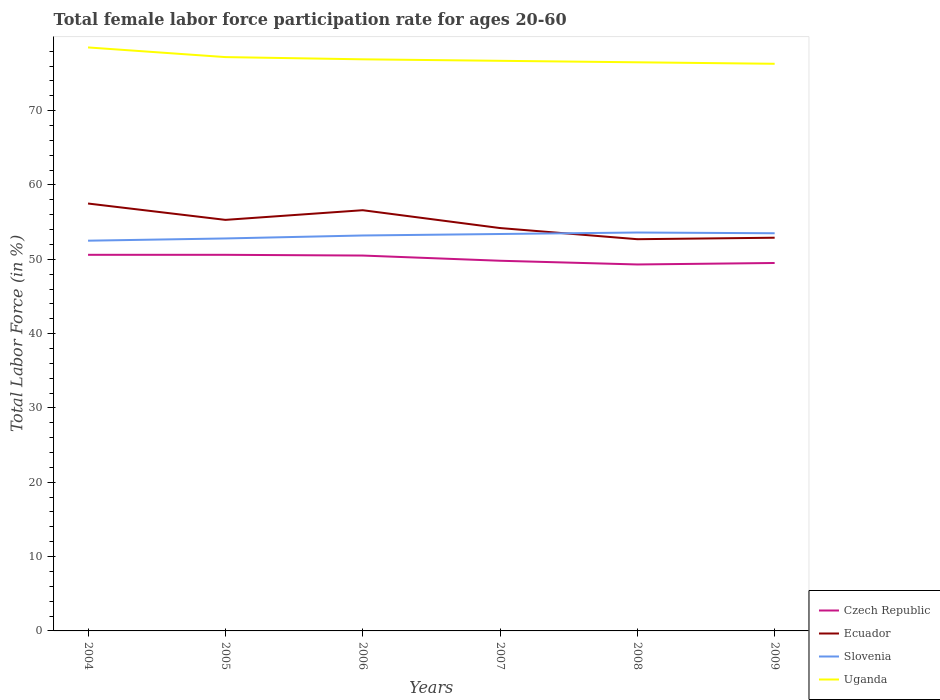How many different coloured lines are there?
Make the answer very short. 4. Does the line corresponding to Czech Republic intersect with the line corresponding to Slovenia?
Ensure brevity in your answer.  No. Is the number of lines equal to the number of legend labels?
Your answer should be compact. Yes. Across all years, what is the maximum female labor force participation rate in Uganda?
Ensure brevity in your answer.  76.3. In which year was the female labor force participation rate in Uganda maximum?
Your answer should be compact. 2009. What is the total female labor force participation rate in Ecuador in the graph?
Make the answer very short. 3.9. What is the difference between the highest and the second highest female labor force participation rate in Slovenia?
Offer a terse response. 1.1. What is the difference between the highest and the lowest female labor force participation rate in Uganda?
Ensure brevity in your answer.  2. How many lines are there?
Provide a succinct answer. 4. How many years are there in the graph?
Keep it short and to the point. 6. Are the values on the major ticks of Y-axis written in scientific E-notation?
Your answer should be compact. No. How many legend labels are there?
Provide a short and direct response. 4. How are the legend labels stacked?
Your response must be concise. Vertical. What is the title of the graph?
Keep it short and to the point. Total female labor force participation rate for ages 20-60. Does "Iceland" appear as one of the legend labels in the graph?
Offer a terse response. No. What is the Total Labor Force (in %) in Czech Republic in 2004?
Offer a terse response. 50.6. What is the Total Labor Force (in %) in Ecuador in 2004?
Your answer should be very brief. 57.5. What is the Total Labor Force (in %) in Slovenia in 2004?
Make the answer very short. 52.5. What is the Total Labor Force (in %) in Uganda in 2004?
Offer a very short reply. 78.5. What is the Total Labor Force (in %) in Czech Republic in 2005?
Your answer should be very brief. 50.6. What is the Total Labor Force (in %) of Ecuador in 2005?
Offer a terse response. 55.3. What is the Total Labor Force (in %) in Slovenia in 2005?
Your response must be concise. 52.8. What is the Total Labor Force (in %) of Uganda in 2005?
Ensure brevity in your answer.  77.2. What is the Total Labor Force (in %) of Czech Republic in 2006?
Ensure brevity in your answer.  50.5. What is the Total Labor Force (in %) of Ecuador in 2006?
Your response must be concise. 56.6. What is the Total Labor Force (in %) of Slovenia in 2006?
Your answer should be compact. 53.2. What is the Total Labor Force (in %) of Uganda in 2006?
Make the answer very short. 76.9. What is the Total Labor Force (in %) in Czech Republic in 2007?
Provide a short and direct response. 49.8. What is the Total Labor Force (in %) in Ecuador in 2007?
Your answer should be compact. 54.2. What is the Total Labor Force (in %) of Slovenia in 2007?
Offer a terse response. 53.4. What is the Total Labor Force (in %) in Uganda in 2007?
Your answer should be compact. 76.7. What is the Total Labor Force (in %) of Czech Republic in 2008?
Offer a terse response. 49.3. What is the Total Labor Force (in %) of Ecuador in 2008?
Your answer should be compact. 52.7. What is the Total Labor Force (in %) of Slovenia in 2008?
Your answer should be very brief. 53.6. What is the Total Labor Force (in %) in Uganda in 2008?
Keep it short and to the point. 76.5. What is the Total Labor Force (in %) in Czech Republic in 2009?
Make the answer very short. 49.5. What is the Total Labor Force (in %) of Ecuador in 2009?
Offer a terse response. 52.9. What is the Total Labor Force (in %) in Slovenia in 2009?
Provide a short and direct response. 53.5. What is the Total Labor Force (in %) of Uganda in 2009?
Your answer should be very brief. 76.3. Across all years, what is the maximum Total Labor Force (in %) of Czech Republic?
Make the answer very short. 50.6. Across all years, what is the maximum Total Labor Force (in %) in Ecuador?
Give a very brief answer. 57.5. Across all years, what is the maximum Total Labor Force (in %) in Slovenia?
Offer a very short reply. 53.6. Across all years, what is the maximum Total Labor Force (in %) in Uganda?
Keep it short and to the point. 78.5. Across all years, what is the minimum Total Labor Force (in %) of Czech Republic?
Provide a succinct answer. 49.3. Across all years, what is the minimum Total Labor Force (in %) of Ecuador?
Your answer should be very brief. 52.7. Across all years, what is the minimum Total Labor Force (in %) of Slovenia?
Keep it short and to the point. 52.5. Across all years, what is the minimum Total Labor Force (in %) of Uganda?
Your answer should be very brief. 76.3. What is the total Total Labor Force (in %) of Czech Republic in the graph?
Your answer should be very brief. 300.3. What is the total Total Labor Force (in %) of Ecuador in the graph?
Provide a succinct answer. 329.2. What is the total Total Labor Force (in %) in Slovenia in the graph?
Give a very brief answer. 319. What is the total Total Labor Force (in %) in Uganda in the graph?
Provide a succinct answer. 462.1. What is the difference between the Total Labor Force (in %) of Czech Republic in 2004 and that in 2006?
Give a very brief answer. 0.1. What is the difference between the Total Labor Force (in %) of Uganda in 2004 and that in 2006?
Offer a terse response. 1.6. What is the difference between the Total Labor Force (in %) of Czech Republic in 2004 and that in 2007?
Your response must be concise. 0.8. What is the difference between the Total Labor Force (in %) in Ecuador in 2004 and that in 2007?
Offer a very short reply. 3.3. What is the difference between the Total Labor Force (in %) in Slovenia in 2004 and that in 2007?
Give a very brief answer. -0.9. What is the difference between the Total Labor Force (in %) in Uganda in 2004 and that in 2007?
Ensure brevity in your answer.  1.8. What is the difference between the Total Labor Force (in %) of Czech Republic in 2004 and that in 2008?
Provide a short and direct response. 1.3. What is the difference between the Total Labor Force (in %) in Ecuador in 2004 and that in 2008?
Make the answer very short. 4.8. What is the difference between the Total Labor Force (in %) in Slovenia in 2004 and that in 2008?
Ensure brevity in your answer.  -1.1. What is the difference between the Total Labor Force (in %) of Czech Republic in 2004 and that in 2009?
Make the answer very short. 1.1. What is the difference between the Total Labor Force (in %) of Ecuador in 2004 and that in 2009?
Your answer should be very brief. 4.6. What is the difference between the Total Labor Force (in %) of Czech Republic in 2005 and that in 2006?
Provide a succinct answer. 0.1. What is the difference between the Total Labor Force (in %) of Ecuador in 2005 and that in 2006?
Give a very brief answer. -1.3. What is the difference between the Total Labor Force (in %) of Uganda in 2005 and that in 2006?
Your answer should be compact. 0.3. What is the difference between the Total Labor Force (in %) of Czech Republic in 2005 and that in 2007?
Provide a short and direct response. 0.8. What is the difference between the Total Labor Force (in %) of Ecuador in 2005 and that in 2007?
Your answer should be compact. 1.1. What is the difference between the Total Labor Force (in %) in Slovenia in 2005 and that in 2007?
Your answer should be compact. -0.6. What is the difference between the Total Labor Force (in %) of Uganda in 2005 and that in 2007?
Give a very brief answer. 0.5. What is the difference between the Total Labor Force (in %) of Uganda in 2005 and that in 2008?
Your answer should be compact. 0.7. What is the difference between the Total Labor Force (in %) in Czech Republic in 2005 and that in 2009?
Offer a very short reply. 1.1. What is the difference between the Total Labor Force (in %) in Ecuador in 2005 and that in 2009?
Give a very brief answer. 2.4. What is the difference between the Total Labor Force (in %) of Czech Republic in 2006 and that in 2007?
Keep it short and to the point. 0.7. What is the difference between the Total Labor Force (in %) in Slovenia in 2006 and that in 2007?
Provide a succinct answer. -0.2. What is the difference between the Total Labor Force (in %) in Czech Republic in 2006 and that in 2008?
Provide a short and direct response. 1.2. What is the difference between the Total Labor Force (in %) of Ecuador in 2006 and that in 2008?
Keep it short and to the point. 3.9. What is the difference between the Total Labor Force (in %) in Slovenia in 2006 and that in 2008?
Offer a terse response. -0.4. What is the difference between the Total Labor Force (in %) of Uganda in 2006 and that in 2008?
Your answer should be compact. 0.4. What is the difference between the Total Labor Force (in %) of Ecuador in 2006 and that in 2009?
Provide a short and direct response. 3.7. What is the difference between the Total Labor Force (in %) in Slovenia in 2006 and that in 2009?
Keep it short and to the point. -0.3. What is the difference between the Total Labor Force (in %) of Uganda in 2006 and that in 2009?
Make the answer very short. 0.6. What is the difference between the Total Labor Force (in %) of Uganda in 2007 and that in 2008?
Your response must be concise. 0.2. What is the difference between the Total Labor Force (in %) of Slovenia in 2007 and that in 2009?
Your response must be concise. -0.1. What is the difference between the Total Labor Force (in %) of Uganda in 2007 and that in 2009?
Provide a succinct answer. 0.4. What is the difference between the Total Labor Force (in %) in Czech Republic in 2008 and that in 2009?
Offer a very short reply. -0.2. What is the difference between the Total Labor Force (in %) in Ecuador in 2008 and that in 2009?
Make the answer very short. -0.2. What is the difference between the Total Labor Force (in %) in Slovenia in 2008 and that in 2009?
Your answer should be very brief. 0.1. What is the difference between the Total Labor Force (in %) in Uganda in 2008 and that in 2009?
Offer a very short reply. 0.2. What is the difference between the Total Labor Force (in %) of Czech Republic in 2004 and the Total Labor Force (in %) of Ecuador in 2005?
Your answer should be very brief. -4.7. What is the difference between the Total Labor Force (in %) of Czech Republic in 2004 and the Total Labor Force (in %) of Slovenia in 2005?
Your response must be concise. -2.2. What is the difference between the Total Labor Force (in %) of Czech Republic in 2004 and the Total Labor Force (in %) of Uganda in 2005?
Offer a terse response. -26.6. What is the difference between the Total Labor Force (in %) of Ecuador in 2004 and the Total Labor Force (in %) of Uganda in 2005?
Provide a succinct answer. -19.7. What is the difference between the Total Labor Force (in %) of Slovenia in 2004 and the Total Labor Force (in %) of Uganda in 2005?
Provide a succinct answer. -24.7. What is the difference between the Total Labor Force (in %) in Czech Republic in 2004 and the Total Labor Force (in %) in Slovenia in 2006?
Ensure brevity in your answer.  -2.6. What is the difference between the Total Labor Force (in %) in Czech Republic in 2004 and the Total Labor Force (in %) in Uganda in 2006?
Keep it short and to the point. -26.3. What is the difference between the Total Labor Force (in %) in Ecuador in 2004 and the Total Labor Force (in %) in Uganda in 2006?
Provide a short and direct response. -19.4. What is the difference between the Total Labor Force (in %) of Slovenia in 2004 and the Total Labor Force (in %) of Uganda in 2006?
Your response must be concise. -24.4. What is the difference between the Total Labor Force (in %) in Czech Republic in 2004 and the Total Labor Force (in %) in Ecuador in 2007?
Offer a very short reply. -3.6. What is the difference between the Total Labor Force (in %) in Czech Republic in 2004 and the Total Labor Force (in %) in Uganda in 2007?
Provide a succinct answer. -26.1. What is the difference between the Total Labor Force (in %) of Ecuador in 2004 and the Total Labor Force (in %) of Slovenia in 2007?
Your answer should be compact. 4.1. What is the difference between the Total Labor Force (in %) of Ecuador in 2004 and the Total Labor Force (in %) of Uganda in 2007?
Offer a very short reply. -19.2. What is the difference between the Total Labor Force (in %) of Slovenia in 2004 and the Total Labor Force (in %) of Uganda in 2007?
Provide a succinct answer. -24.2. What is the difference between the Total Labor Force (in %) in Czech Republic in 2004 and the Total Labor Force (in %) in Ecuador in 2008?
Give a very brief answer. -2.1. What is the difference between the Total Labor Force (in %) in Czech Republic in 2004 and the Total Labor Force (in %) in Slovenia in 2008?
Make the answer very short. -3. What is the difference between the Total Labor Force (in %) in Czech Republic in 2004 and the Total Labor Force (in %) in Uganda in 2008?
Your response must be concise. -25.9. What is the difference between the Total Labor Force (in %) in Ecuador in 2004 and the Total Labor Force (in %) in Slovenia in 2008?
Offer a terse response. 3.9. What is the difference between the Total Labor Force (in %) in Ecuador in 2004 and the Total Labor Force (in %) in Uganda in 2008?
Make the answer very short. -19. What is the difference between the Total Labor Force (in %) of Czech Republic in 2004 and the Total Labor Force (in %) of Ecuador in 2009?
Your answer should be compact. -2.3. What is the difference between the Total Labor Force (in %) in Czech Republic in 2004 and the Total Labor Force (in %) in Slovenia in 2009?
Give a very brief answer. -2.9. What is the difference between the Total Labor Force (in %) of Czech Republic in 2004 and the Total Labor Force (in %) of Uganda in 2009?
Your response must be concise. -25.7. What is the difference between the Total Labor Force (in %) of Ecuador in 2004 and the Total Labor Force (in %) of Uganda in 2009?
Keep it short and to the point. -18.8. What is the difference between the Total Labor Force (in %) in Slovenia in 2004 and the Total Labor Force (in %) in Uganda in 2009?
Provide a succinct answer. -23.8. What is the difference between the Total Labor Force (in %) of Czech Republic in 2005 and the Total Labor Force (in %) of Slovenia in 2006?
Ensure brevity in your answer.  -2.6. What is the difference between the Total Labor Force (in %) in Czech Republic in 2005 and the Total Labor Force (in %) in Uganda in 2006?
Provide a short and direct response. -26.3. What is the difference between the Total Labor Force (in %) of Ecuador in 2005 and the Total Labor Force (in %) of Uganda in 2006?
Your response must be concise. -21.6. What is the difference between the Total Labor Force (in %) in Slovenia in 2005 and the Total Labor Force (in %) in Uganda in 2006?
Offer a very short reply. -24.1. What is the difference between the Total Labor Force (in %) of Czech Republic in 2005 and the Total Labor Force (in %) of Uganda in 2007?
Keep it short and to the point. -26.1. What is the difference between the Total Labor Force (in %) in Ecuador in 2005 and the Total Labor Force (in %) in Uganda in 2007?
Your answer should be compact. -21.4. What is the difference between the Total Labor Force (in %) in Slovenia in 2005 and the Total Labor Force (in %) in Uganda in 2007?
Provide a short and direct response. -23.9. What is the difference between the Total Labor Force (in %) of Czech Republic in 2005 and the Total Labor Force (in %) of Ecuador in 2008?
Provide a succinct answer. -2.1. What is the difference between the Total Labor Force (in %) in Czech Republic in 2005 and the Total Labor Force (in %) in Uganda in 2008?
Your response must be concise. -25.9. What is the difference between the Total Labor Force (in %) of Ecuador in 2005 and the Total Labor Force (in %) of Uganda in 2008?
Provide a short and direct response. -21.2. What is the difference between the Total Labor Force (in %) of Slovenia in 2005 and the Total Labor Force (in %) of Uganda in 2008?
Offer a very short reply. -23.7. What is the difference between the Total Labor Force (in %) in Czech Republic in 2005 and the Total Labor Force (in %) in Slovenia in 2009?
Keep it short and to the point. -2.9. What is the difference between the Total Labor Force (in %) of Czech Republic in 2005 and the Total Labor Force (in %) of Uganda in 2009?
Provide a succinct answer. -25.7. What is the difference between the Total Labor Force (in %) of Ecuador in 2005 and the Total Labor Force (in %) of Slovenia in 2009?
Ensure brevity in your answer.  1.8. What is the difference between the Total Labor Force (in %) in Ecuador in 2005 and the Total Labor Force (in %) in Uganda in 2009?
Your answer should be very brief. -21. What is the difference between the Total Labor Force (in %) in Slovenia in 2005 and the Total Labor Force (in %) in Uganda in 2009?
Make the answer very short. -23.5. What is the difference between the Total Labor Force (in %) of Czech Republic in 2006 and the Total Labor Force (in %) of Ecuador in 2007?
Make the answer very short. -3.7. What is the difference between the Total Labor Force (in %) of Czech Republic in 2006 and the Total Labor Force (in %) of Uganda in 2007?
Make the answer very short. -26.2. What is the difference between the Total Labor Force (in %) of Ecuador in 2006 and the Total Labor Force (in %) of Uganda in 2007?
Keep it short and to the point. -20.1. What is the difference between the Total Labor Force (in %) in Slovenia in 2006 and the Total Labor Force (in %) in Uganda in 2007?
Your answer should be compact. -23.5. What is the difference between the Total Labor Force (in %) of Czech Republic in 2006 and the Total Labor Force (in %) of Ecuador in 2008?
Keep it short and to the point. -2.2. What is the difference between the Total Labor Force (in %) in Czech Republic in 2006 and the Total Labor Force (in %) in Slovenia in 2008?
Your answer should be very brief. -3.1. What is the difference between the Total Labor Force (in %) in Czech Republic in 2006 and the Total Labor Force (in %) in Uganda in 2008?
Your answer should be very brief. -26. What is the difference between the Total Labor Force (in %) in Ecuador in 2006 and the Total Labor Force (in %) in Slovenia in 2008?
Make the answer very short. 3. What is the difference between the Total Labor Force (in %) of Ecuador in 2006 and the Total Labor Force (in %) of Uganda in 2008?
Provide a succinct answer. -19.9. What is the difference between the Total Labor Force (in %) of Slovenia in 2006 and the Total Labor Force (in %) of Uganda in 2008?
Offer a terse response. -23.3. What is the difference between the Total Labor Force (in %) of Czech Republic in 2006 and the Total Labor Force (in %) of Ecuador in 2009?
Your answer should be very brief. -2.4. What is the difference between the Total Labor Force (in %) in Czech Republic in 2006 and the Total Labor Force (in %) in Slovenia in 2009?
Your response must be concise. -3. What is the difference between the Total Labor Force (in %) in Czech Republic in 2006 and the Total Labor Force (in %) in Uganda in 2009?
Your answer should be very brief. -25.8. What is the difference between the Total Labor Force (in %) of Ecuador in 2006 and the Total Labor Force (in %) of Uganda in 2009?
Offer a terse response. -19.7. What is the difference between the Total Labor Force (in %) in Slovenia in 2006 and the Total Labor Force (in %) in Uganda in 2009?
Ensure brevity in your answer.  -23.1. What is the difference between the Total Labor Force (in %) in Czech Republic in 2007 and the Total Labor Force (in %) in Ecuador in 2008?
Provide a short and direct response. -2.9. What is the difference between the Total Labor Force (in %) in Czech Republic in 2007 and the Total Labor Force (in %) in Slovenia in 2008?
Your answer should be very brief. -3.8. What is the difference between the Total Labor Force (in %) in Czech Republic in 2007 and the Total Labor Force (in %) in Uganda in 2008?
Offer a very short reply. -26.7. What is the difference between the Total Labor Force (in %) of Ecuador in 2007 and the Total Labor Force (in %) of Uganda in 2008?
Provide a succinct answer. -22.3. What is the difference between the Total Labor Force (in %) of Slovenia in 2007 and the Total Labor Force (in %) of Uganda in 2008?
Make the answer very short. -23.1. What is the difference between the Total Labor Force (in %) in Czech Republic in 2007 and the Total Labor Force (in %) in Slovenia in 2009?
Make the answer very short. -3.7. What is the difference between the Total Labor Force (in %) of Czech Republic in 2007 and the Total Labor Force (in %) of Uganda in 2009?
Offer a very short reply. -26.5. What is the difference between the Total Labor Force (in %) in Ecuador in 2007 and the Total Labor Force (in %) in Slovenia in 2009?
Give a very brief answer. 0.7. What is the difference between the Total Labor Force (in %) in Ecuador in 2007 and the Total Labor Force (in %) in Uganda in 2009?
Your answer should be very brief. -22.1. What is the difference between the Total Labor Force (in %) in Slovenia in 2007 and the Total Labor Force (in %) in Uganda in 2009?
Ensure brevity in your answer.  -22.9. What is the difference between the Total Labor Force (in %) of Czech Republic in 2008 and the Total Labor Force (in %) of Ecuador in 2009?
Offer a terse response. -3.6. What is the difference between the Total Labor Force (in %) of Ecuador in 2008 and the Total Labor Force (in %) of Uganda in 2009?
Offer a terse response. -23.6. What is the difference between the Total Labor Force (in %) in Slovenia in 2008 and the Total Labor Force (in %) in Uganda in 2009?
Keep it short and to the point. -22.7. What is the average Total Labor Force (in %) in Czech Republic per year?
Provide a succinct answer. 50.05. What is the average Total Labor Force (in %) of Ecuador per year?
Your answer should be very brief. 54.87. What is the average Total Labor Force (in %) in Slovenia per year?
Provide a succinct answer. 53.17. What is the average Total Labor Force (in %) in Uganda per year?
Provide a succinct answer. 77.02. In the year 2004, what is the difference between the Total Labor Force (in %) in Czech Republic and Total Labor Force (in %) in Slovenia?
Offer a very short reply. -1.9. In the year 2004, what is the difference between the Total Labor Force (in %) in Czech Republic and Total Labor Force (in %) in Uganda?
Your answer should be compact. -27.9. In the year 2004, what is the difference between the Total Labor Force (in %) of Slovenia and Total Labor Force (in %) of Uganda?
Offer a very short reply. -26. In the year 2005, what is the difference between the Total Labor Force (in %) in Czech Republic and Total Labor Force (in %) in Uganda?
Provide a short and direct response. -26.6. In the year 2005, what is the difference between the Total Labor Force (in %) of Ecuador and Total Labor Force (in %) of Uganda?
Make the answer very short. -21.9. In the year 2005, what is the difference between the Total Labor Force (in %) in Slovenia and Total Labor Force (in %) in Uganda?
Offer a terse response. -24.4. In the year 2006, what is the difference between the Total Labor Force (in %) in Czech Republic and Total Labor Force (in %) in Uganda?
Provide a succinct answer. -26.4. In the year 2006, what is the difference between the Total Labor Force (in %) in Ecuador and Total Labor Force (in %) in Slovenia?
Offer a terse response. 3.4. In the year 2006, what is the difference between the Total Labor Force (in %) in Ecuador and Total Labor Force (in %) in Uganda?
Keep it short and to the point. -20.3. In the year 2006, what is the difference between the Total Labor Force (in %) in Slovenia and Total Labor Force (in %) in Uganda?
Provide a short and direct response. -23.7. In the year 2007, what is the difference between the Total Labor Force (in %) of Czech Republic and Total Labor Force (in %) of Slovenia?
Make the answer very short. -3.6. In the year 2007, what is the difference between the Total Labor Force (in %) of Czech Republic and Total Labor Force (in %) of Uganda?
Give a very brief answer. -26.9. In the year 2007, what is the difference between the Total Labor Force (in %) in Ecuador and Total Labor Force (in %) in Slovenia?
Keep it short and to the point. 0.8. In the year 2007, what is the difference between the Total Labor Force (in %) in Ecuador and Total Labor Force (in %) in Uganda?
Your answer should be very brief. -22.5. In the year 2007, what is the difference between the Total Labor Force (in %) in Slovenia and Total Labor Force (in %) in Uganda?
Give a very brief answer. -23.3. In the year 2008, what is the difference between the Total Labor Force (in %) in Czech Republic and Total Labor Force (in %) in Ecuador?
Your answer should be compact. -3.4. In the year 2008, what is the difference between the Total Labor Force (in %) of Czech Republic and Total Labor Force (in %) of Uganda?
Provide a succinct answer. -27.2. In the year 2008, what is the difference between the Total Labor Force (in %) of Ecuador and Total Labor Force (in %) of Slovenia?
Your answer should be very brief. -0.9. In the year 2008, what is the difference between the Total Labor Force (in %) in Ecuador and Total Labor Force (in %) in Uganda?
Ensure brevity in your answer.  -23.8. In the year 2008, what is the difference between the Total Labor Force (in %) of Slovenia and Total Labor Force (in %) of Uganda?
Ensure brevity in your answer.  -22.9. In the year 2009, what is the difference between the Total Labor Force (in %) of Czech Republic and Total Labor Force (in %) of Slovenia?
Ensure brevity in your answer.  -4. In the year 2009, what is the difference between the Total Labor Force (in %) of Czech Republic and Total Labor Force (in %) of Uganda?
Give a very brief answer. -26.8. In the year 2009, what is the difference between the Total Labor Force (in %) in Ecuador and Total Labor Force (in %) in Uganda?
Provide a succinct answer. -23.4. In the year 2009, what is the difference between the Total Labor Force (in %) of Slovenia and Total Labor Force (in %) of Uganda?
Offer a terse response. -22.8. What is the ratio of the Total Labor Force (in %) in Czech Republic in 2004 to that in 2005?
Offer a terse response. 1. What is the ratio of the Total Labor Force (in %) in Ecuador in 2004 to that in 2005?
Provide a succinct answer. 1.04. What is the ratio of the Total Labor Force (in %) of Uganda in 2004 to that in 2005?
Ensure brevity in your answer.  1.02. What is the ratio of the Total Labor Force (in %) in Ecuador in 2004 to that in 2006?
Provide a succinct answer. 1.02. What is the ratio of the Total Labor Force (in %) of Slovenia in 2004 to that in 2006?
Give a very brief answer. 0.99. What is the ratio of the Total Labor Force (in %) of Uganda in 2004 to that in 2006?
Your answer should be compact. 1.02. What is the ratio of the Total Labor Force (in %) in Czech Republic in 2004 to that in 2007?
Provide a succinct answer. 1.02. What is the ratio of the Total Labor Force (in %) of Ecuador in 2004 to that in 2007?
Offer a terse response. 1.06. What is the ratio of the Total Labor Force (in %) in Slovenia in 2004 to that in 2007?
Give a very brief answer. 0.98. What is the ratio of the Total Labor Force (in %) of Uganda in 2004 to that in 2007?
Offer a very short reply. 1.02. What is the ratio of the Total Labor Force (in %) of Czech Republic in 2004 to that in 2008?
Offer a very short reply. 1.03. What is the ratio of the Total Labor Force (in %) in Ecuador in 2004 to that in 2008?
Offer a very short reply. 1.09. What is the ratio of the Total Labor Force (in %) in Slovenia in 2004 to that in 2008?
Provide a succinct answer. 0.98. What is the ratio of the Total Labor Force (in %) in Uganda in 2004 to that in 2008?
Offer a terse response. 1.03. What is the ratio of the Total Labor Force (in %) of Czech Republic in 2004 to that in 2009?
Offer a very short reply. 1.02. What is the ratio of the Total Labor Force (in %) of Ecuador in 2004 to that in 2009?
Provide a succinct answer. 1.09. What is the ratio of the Total Labor Force (in %) in Slovenia in 2004 to that in 2009?
Keep it short and to the point. 0.98. What is the ratio of the Total Labor Force (in %) in Uganda in 2004 to that in 2009?
Make the answer very short. 1.03. What is the ratio of the Total Labor Force (in %) in Czech Republic in 2005 to that in 2006?
Ensure brevity in your answer.  1. What is the ratio of the Total Labor Force (in %) in Ecuador in 2005 to that in 2006?
Provide a short and direct response. 0.98. What is the ratio of the Total Labor Force (in %) in Slovenia in 2005 to that in 2006?
Provide a succinct answer. 0.99. What is the ratio of the Total Labor Force (in %) in Uganda in 2005 to that in 2006?
Your answer should be very brief. 1. What is the ratio of the Total Labor Force (in %) in Czech Republic in 2005 to that in 2007?
Provide a short and direct response. 1.02. What is the ratio of the Total Labor Force (in %) of Ecuador in 2005 to that in 2007?
Your response must be concise. 1.02. What is the ratio of the Total Labor Force (in %) of Slovenia in 2005 to that in 2007?
Make the answer very short. 0.99. What is the ratio of the Total Labor Force (in %) of Czech Republic in 2005 to that in 2008?
Provide a succinct answer. 1.03. What is the ratio of the Total Labor Force (in %) in Ecuador in 2005 to that in 2008?
Make the answer very short. 1.05. What is the ratio of the Total Labor Force (in %) of Slovenia in 2005 to that in 2008?
Give a very brief answer. 0.99. What is the ratio of the Total Labor Force (in %) of Uganda in 2005 to that in 2008?
Offer a terse response. 1.01. What is the ratio of the Total Labor Force (in %) in Czech Republic in 2005 to that in 2009?
Ensure brevity in your answer.  1.02. What is the ratio of the Total Labor Force (in %) of Ecuador in 2005 to that in 2009?
Make the answer very short. 1.05. What is the ratio of the Total Labor Force (in %) of Slovenia in 2005 to that in 2009?
Keep it short and to the point. 0.99. What is the ratio of the Total Labor Force (in %) of Uganda in 2005 to that in 2009?
Provide a short and direct response. 1.01. What is the ratio of the Total Labor Force (in %) in Czech Republic in 2006 to that in 2007?
Make the answer very short. 1.01. What is the ratio of the Total Labor Force (in %) of Ecuador in 2006 to that in 2007?
Your answer should be compact. 1.04. What is the ratio of the Total Labor Force (in %) of Czech Republic in 2006 to that in 2008?
Ensure brevity in your answer.  1.02. What is the ratio of the Total Labor Force (in %) of Ecuador in 2006 to that in 2008?
Your answer should be very brief. 1.07. What is the ratio of the Total Labor Force (in %) in Slovenia in 2006 to that in 2008?
Your answer should be compact. 0.99. What is the ratio of the Total Labor Force (in %) of Uganda in 2006 to that in 2008?
Give a very brief answer. 1.01. What is the ratio of the Total Labor Force (in %) of Czech Republic in 2006 to that in 2009?
Your answer should be very brief. 1.02. What is the ratio of the Total Labor Force (in %) of Ecuador in 2006 to that in 2009?
Offer a terse response. 1.07. What is the ratio of the Total Labor Force (in %) in Uganda in 2006 to that in 2009?
Ensure brevity in your answer.  1.01. What is the ratio of the Total Labor Force (in %) in Czech Republic in 2007 to that in 2008?
Give a very brief answer. 1.01. What is the ratio of the Total Labor Force (in %) in Ecuador in 2007 to that in 2008?
Make the answer very short. 1.03. What is the ratio of the Total Labor Force (in %) of Uganda in 2007 to that in 2008?
Provide a short and direct response. 1. What is the ratio of the Total Labor Force (in %) of Czech Republic in 2007 to that in 2009?
Ensure brevity in your answer.  1.01. What is the ratio of the Total Labor Force (in %) of Ecuador in 2007 to that in 2009?
Your answer should be compact. 1.02. What is the ratio of the Total Labor Force (in %) of Slovenia in 2007 to that in 2009?
Give a very brief answer. 1. What is the ratio of the Total Labor Force (in %) in Czech Republic in 2008 to that in 2009?
Your response must be concise. 1. What is the ratio of the Total Labor Force (in %) in Ecuador in 2008 to that in 2009?
Your response must be concise. 1. What is the ratio of the Total Labor Force (in %) in Slovenia in 2008 to that in 2009?
Make the answer very short. 1. What is the difference between the highest and the second highest Total Labor Force (in %) in Czech Republic?
Your answer should be compact. 0. What is the difference between the highest and the second highest Total Labor Force (in %) in Ecuador?
Ensure brevity in your answer.  0.9. What is the difference between the highest and the second highest Total Labor Force (in %) in Slovenia?
Your answer should be compact. 0.1. What is the difference between the highest and the lowest Total Labor Force (in %) in Czech Republic?
Keep it short and to the point. 1.3. What is the difference between the highest and the lowest Total Labor Force (in %) of Ecuador?
Offer a very short reply. 4.8. What is the difference between the highest and the lowest Total Labor Force (in %) in Slovenia?
Keep it short and to the point. 1.1. What is the difference between the highest and the lowest Total Labor Force (in %) in Uganda?
Make the answer very short. 2.2. 